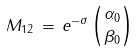Convert formula to latex. <formula><loc_0><loc_0><loc_500><loc_500>M _ { 1 2 } \, = \, e ^ { - \sigma } \, { \alpha _ { 0 } \choose \beta _ { 0 } }</formula> 